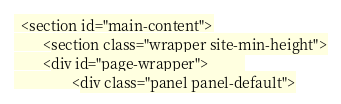<code> <loc_0><loc_0><loc_500><loc_500><_PHP_>  <section id="main-content">
    	<section class="wrapper site-min-height">
      	<div id="page-wrapper">      	
        		<div class="panel panel-default"></code> 